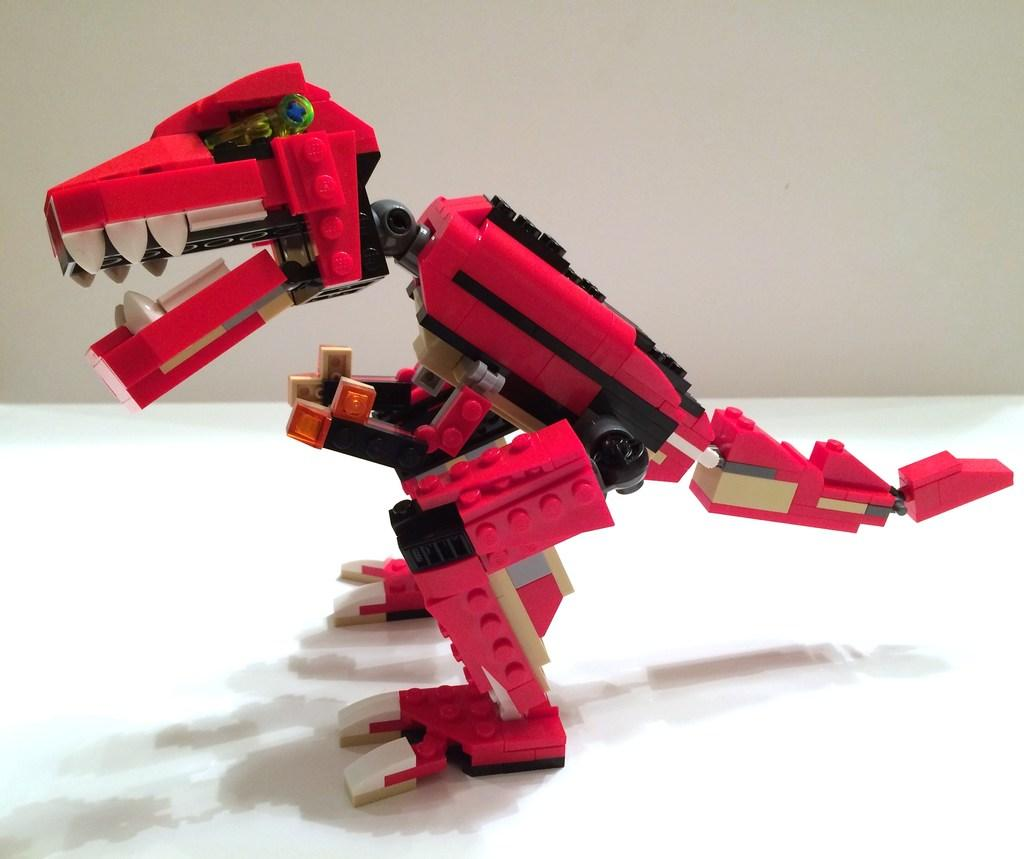What color is the toy that is visible in the image? The toy is red in color. Where is the toy located in the image? The toy is in the front of the image. What can be seen in the background of the image? There is a wall in the background of the image. How many cacti are growing on the wall in the image? There are no cacti visible in the image; only a wall is present in the background. 